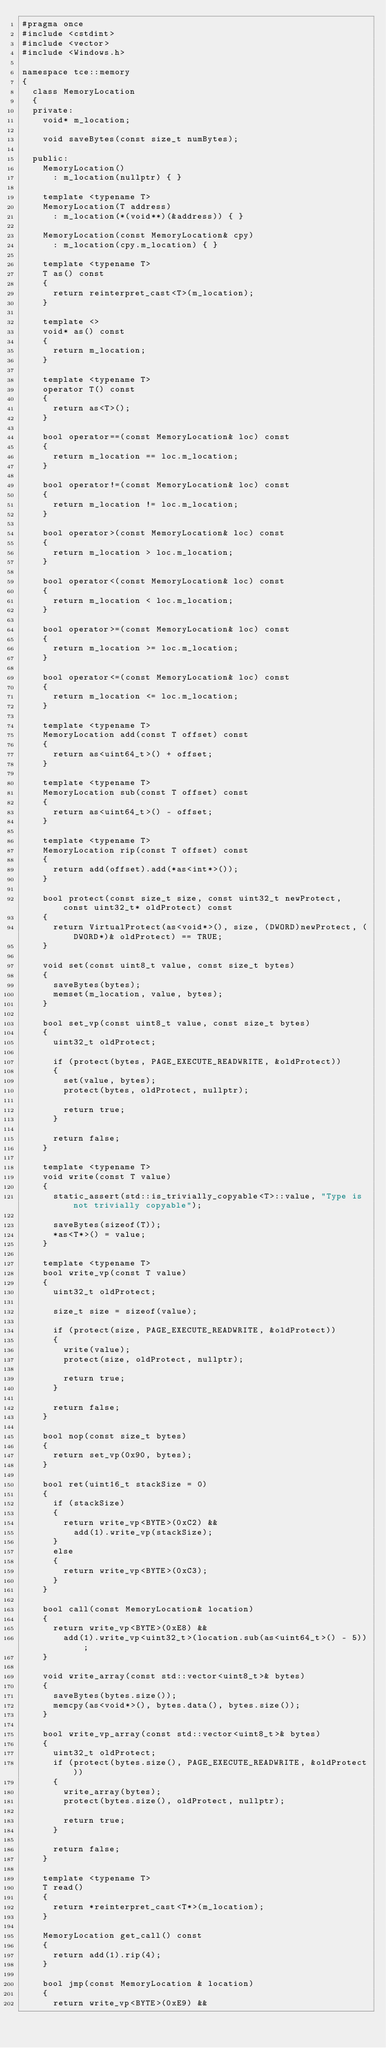Convert code to text. <code><loc_0><loc_0><loc_500><loc_500><_C++_>#pragma once
#include <cstdint>
#include <vector>
#include <Windows.h>

namespace tce::memory
{
	class MemoryLocation
	{
	private:
		void* m_location;

		void saveBytes(const size_t numBytes);

	public:
		MemoryLocation()
			: m_location(nullptr) { }

		template <typename T>
		MemoryLocation(T address)
			: m_location(*(void**)(&address)) { }

		MemoryLocation(const MemoryLocation& cpy)
			: m_location(cpy.m_location) { }

		template <typename T>
		T as() const
		{
			return reinterpret_cast<T>(m_location);
		}

		template <>
		void* as() const
		{
			return m_location;
		}

		template <typename T>
		operator T() const
		{
			return as<T>();
		}

		bool operator==(const MemoryLocation& loc) const
		{
			return m_location == loc.m_location;
		}

		bool operator!=(const MemoryLocation& loc) const
		{
			return m_location != loc.m_location;
		}

		bool operator>(const MemoryLocation& loc) const
		{
			return m_location > loc.m_location;
		}

		bool operator<(const MemoryLocation& loc) const
		{
			return m_location < loc.m_location;
		}

		bool operator>=(const MemoryLocation& loc) const
		{
			return m_location >= loc.m_location;
		}

		bool operator<=(const MemoryLocation& loc) const
		{
			return m_location <= loc.m_location;
		}

		template <typename T>
		MemoryLocation add(const T offset) const
		{
			return as<uint64_t>() + offset;
		}

		template <typename T>
		MemoryLocation sub(const T offset) const
		{
			return as<uint64_t>() - offset;
		}

		template <typename T>
		MemoryLocation rip(const T offset) const
		{
			return add(offset).add(*as<int*>());
		}

		bool protect(const size_t size, const uint32_t newProtect, const uint32_t* oldProtect) const
		{
			return VirtualProtect(as<void*>(), size, (DWORD)newProtect, (DWORD*)& oldProtect) == TRUE;
		}

		void set(const uint8_t value, const size_t bytes)
		{
			saveBytes(bytes);
			memset(m_location, value, bytes);
		}

		bool set_vp(const uint8_t value, const size_t bytes)
		{
			uint32_t oldProtect;

			if (protect(bytes, PAGE_EXECUTE_READWRITE, &oldProtect))
			{
				set(value, bytes);
				protect(bytes, oldProtect, nullptr);

				return true;
			}

			return false;
		}

		template <typename T>
		void write(const T value)
		{
			static_assert(std::is_trivially_copyable<T>::value, "Type is not trivially copyable");

			saveBytes(sizeof(T));
			*as<T*>() = value;
		}

		template <typename T>
		bool write_vp(const T value)
		{
			uint32_t oldProtect;

			size_t size = sizeof(value);

			if (protect(size, PAGE_EXECUTE_READWRITE, &oldProtect))
			{
				write(value);
				protect(size, oldProtect, nullptr);

				return true;
			}

			return false;
		}

		bool nop(const size_t bytes)
		{
			return set_vp(0x90, bytes);
		}

		bool ret(uint16_t stackSize = 0)
		{
			if (stackSize)
			{
				return write_vp<BYTE>(0xC2) &&
					add(1).write_vp(stackSize);
			}
			else
			{
				return write_vp<BYTE>(0xC3);
			}
		}

		bool call(const MemoryLocation& location)
		{
			return write_vp<BYTE>(0xE8) &&
				add(1).write_vp<uint32_t>(location.sub(as<uint64_t>() - 5));
		}

		void write_array(const std::vector<uint8_t>& bytes)
		{
			saveBytes(bytes.size());
			memcpy(as<void*>(), bytes.data(), bytes.size());
		}

		bool write_vp_array(const std::vector<uint8_t>& bytes)
		{
			uint32_t oldProtect;
			if (protect(bytes.size(), PAGE_EXECUTE_READWRITE, &oldProtect))
			{
				write_array(bytes);
				protect(bytes.size(), oldProtect, nullptr);

				return true;
			}
			
			return false;
		}

		template <typename T>
		T read()
		{
			return *reinterpret_cast<T*>(m_location);
		}

		MemoryLocation get_call() const
		{
			return add(1).rip(4);
		}

		bool jmp(const MemoryLocation & location)
		{
			return write_vp<BYTE>(0xE9) &&</code> 